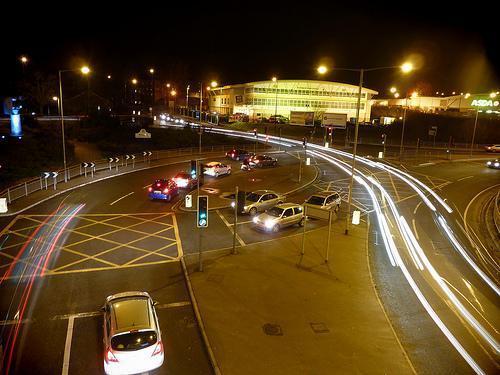How many cars can be seen clearly?
Give a very brief answer. 9. 